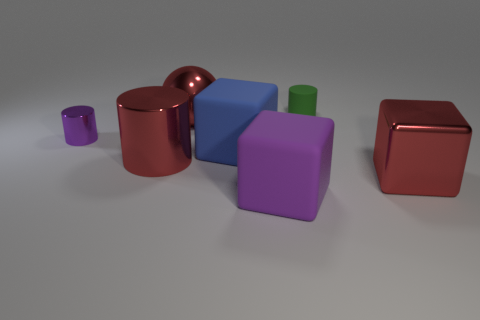Subtract all metal cylinders. How many cylinders are left? 1 Subtract all red blocks. How many blocks are left? 2 Subtract all cubes. How many objects are left? 4 Subtract all gray blocks. Subtract all yellow balls. How many blocks are left? 3 Subtract all green spheres. How many red cylinders are left? 1 Subtract all small green rubber things. Subtract all purple rubber blocks. How many objects are left? 5 Add 2 cylinders. How many cylinders are left? 5 Add 7 large red shiny cylinders. How many large red shiny cylinders exist? 8 Add 3 brown metallic cylinders. How many objects exist? 10 Subtract 0 yellow cylinders. How many objects are left? 7 